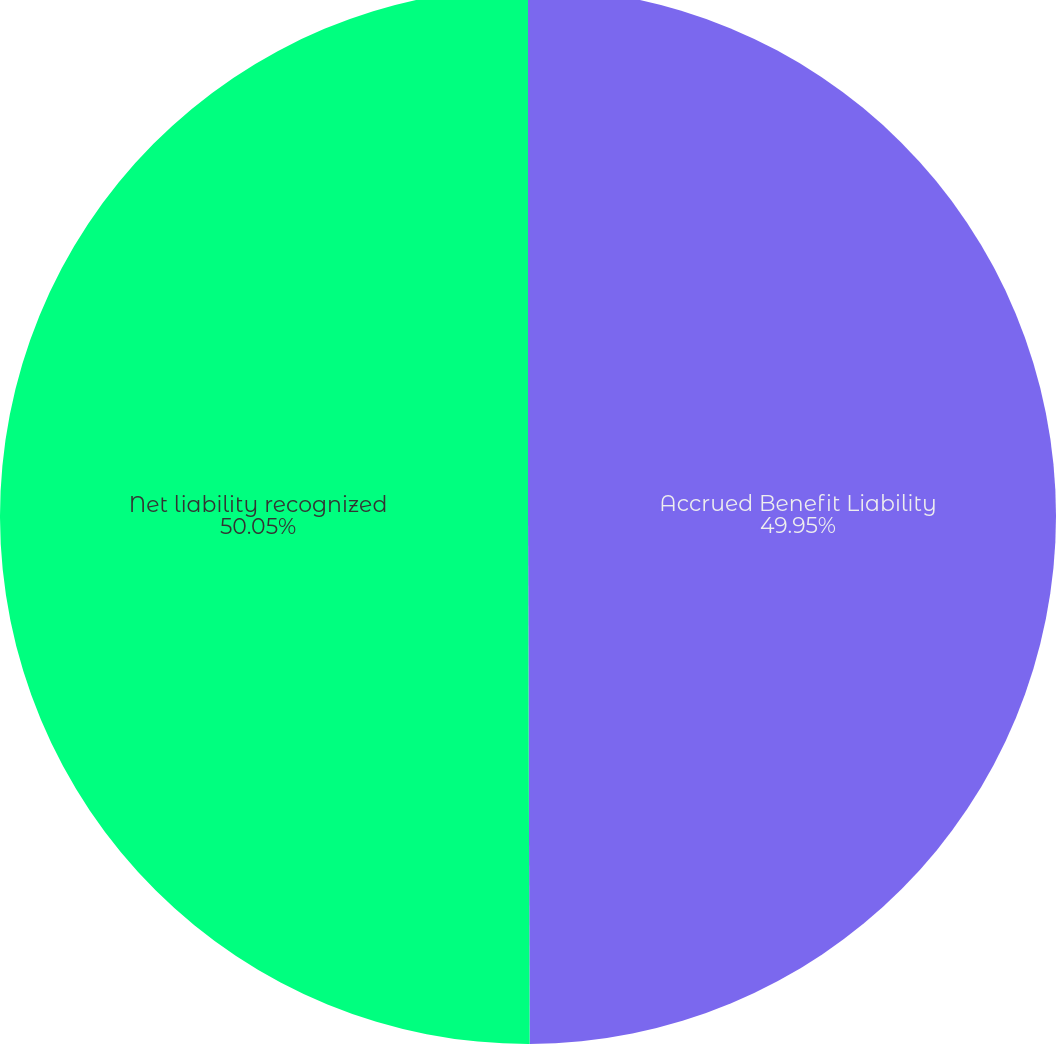Convert chart. <chart><loc_0><loc_0><loc_500><loc_500><pie_chart><fcel>Accrued Benefit Liability<fcel>Net liability recognized<nl><fcel>49.95%<fcel>50.05%<nl></chart> 